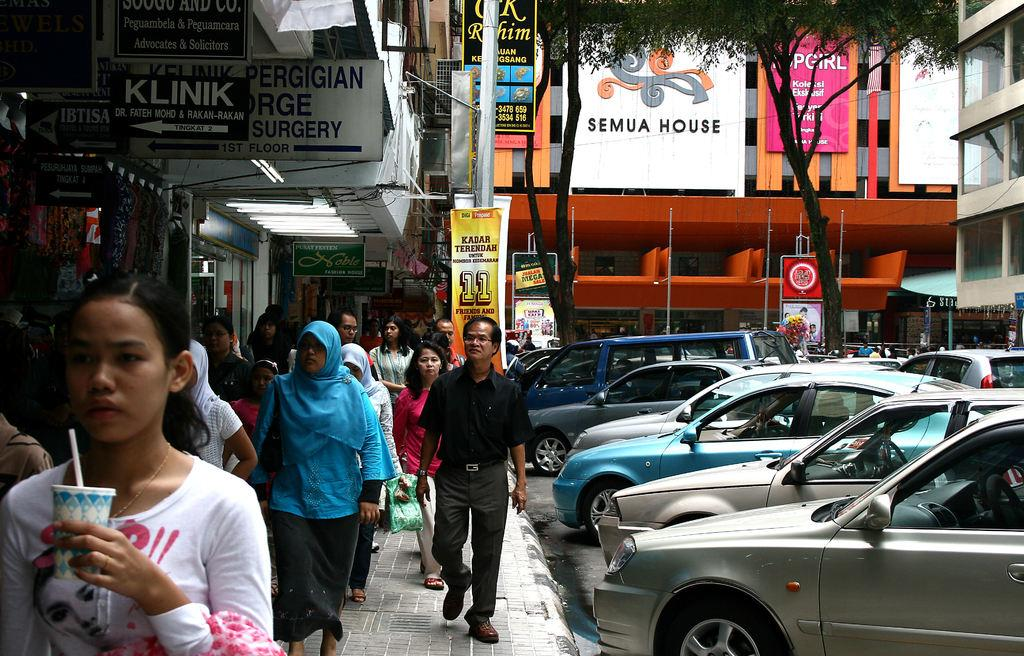<image>
Present a compact description of the photo's key features. Several people walking outside in front of a surgery clinic. 